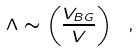Convert formula to latex. <formula><loc_0><loc_0><loc_500><loc_500>\Lambda \sim \left ( \frac { V _ { B G } } { V } \right ) \ ,</formula> 